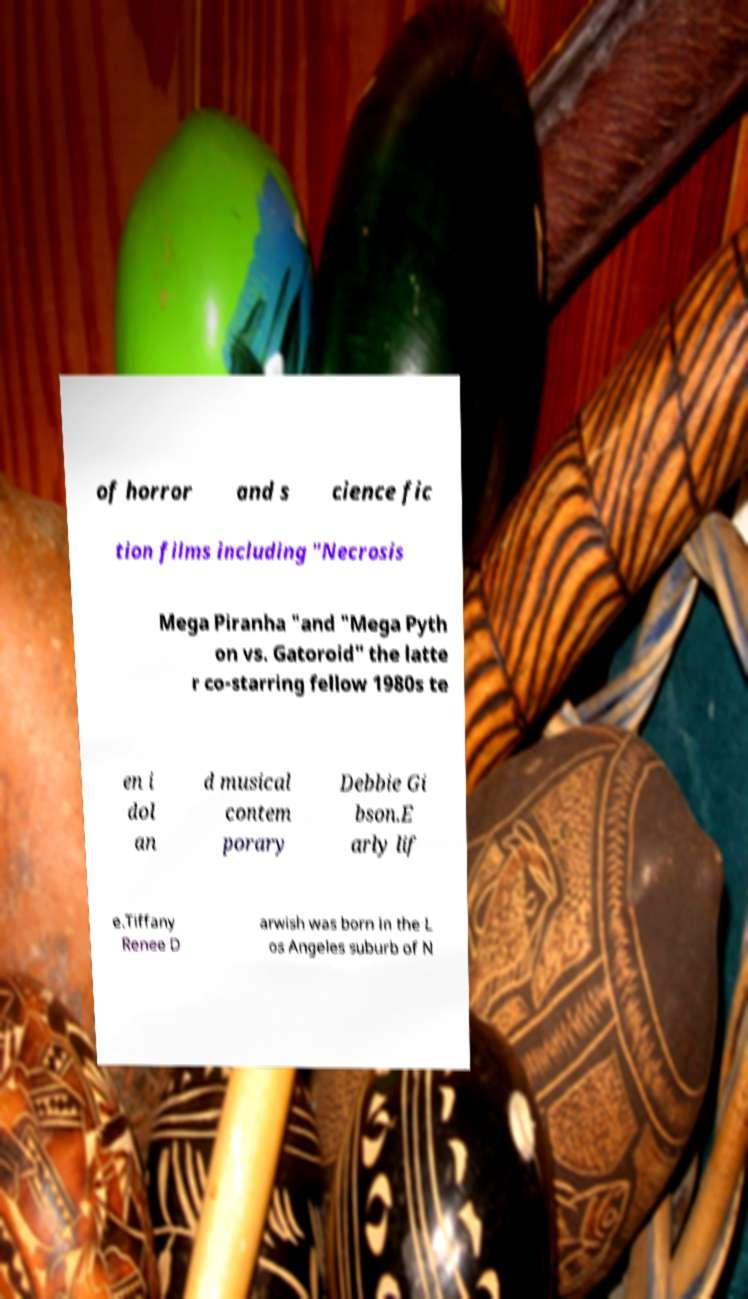Can you accurately transcribe the text from the provided image for me? of horror and s cience fic tion films including "Necrosis Mega Piranha "and "Mega Pyth on vs. Gatoroid" the latte r co-starring fellow 1980s te en i dol an d musical contem porary Debbie Gi bson.E arly lif e.Tiffany Renee D arwish was born in the L os Angeles suburb of N 